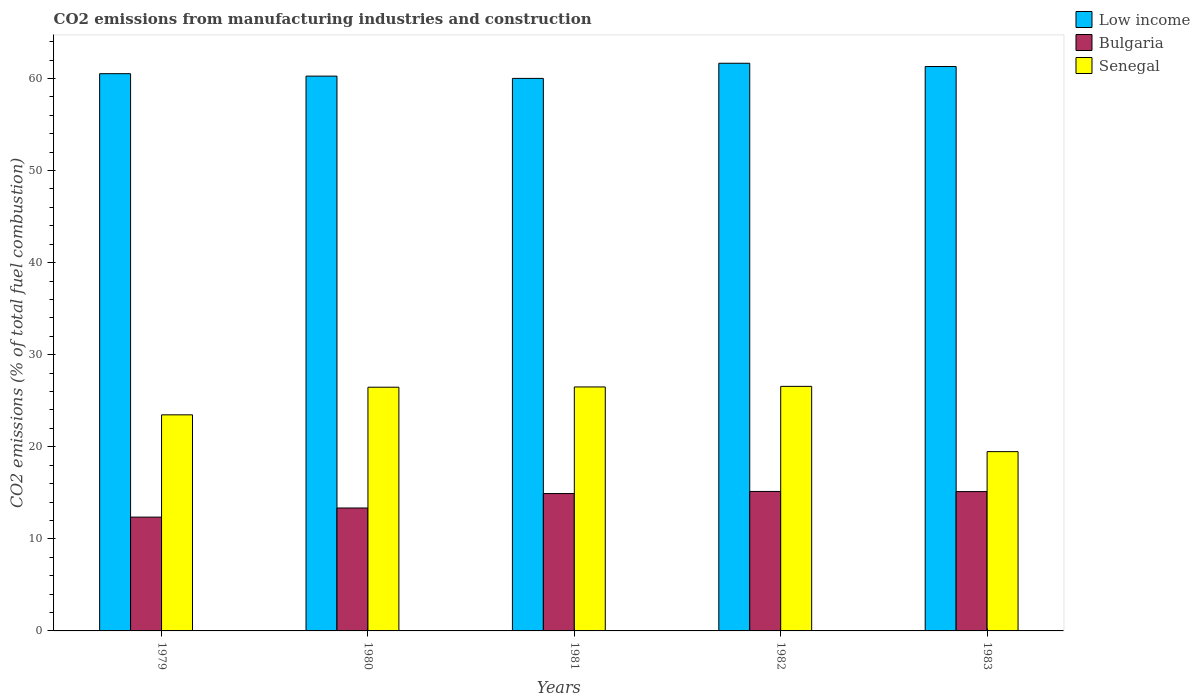How many different coloured bars are there?
Provide a succinct answer. 3. How many groups of bars are there?
Keep it short and to the point. 5. Are the number of bars per tick equal to the number of legend labels?
Provide a succinct answer. Yes. What is the label of the 4th group of bars from the left?
Keep it short and to the point. 1982. What is the amount of CO2 emitted in Senegal in 1983?
Provide a short and direct response. 19.47. Across all years, what is the maximum amount of CO2 emitted in Bulgaria?
Offer a terse response. 15.15. Across all years, what is the minimum amount of CO2 emitted in Bulgaria?
Your answer should be very brief. 12.36. In which year was the amount of CO2 emitted in Senegal maximum?
Provide a short and direct response. 1982. In which year was the amount of CO2 emitted in Bulgaria minimum?
Keep it short and to the point. 1979. What is the total amount of CO2 emitted in Senegal in the graph?
Your answer should be compact. 122.48. What is the difference between the amount of CO2 emitted in Senegal in 1979 and that in 1981?
Provide a succinct answer. -3.03. What is the difference between the amount of CO2 emitted in Bulgaria in 1983 and the amount of CO2 emitted in Low income in 1980?
Your response must be concise. -45.13. What is the average amount of CO2 emitted in Bulgaria per year?
Your response must be concise. 14.18. In the year 1979, what is the difference between the amount of CO2 emitted in Bulgaria and amount of CO2 emitted in Senegal?
Offer a very short reply. -11.11. In how many years, is the amount of CO2 emitted in Senegal greater than 58 %?
Provide a succinct answer. 0. What is the ratio of the amount of CO2 emitted in Senegal in 1980 to that in 1982?
Your answer should be very brief. 1. Is the amount of CO2 emitted in Low income in 1980 less than that in 1981?
Offer a terse response. No. What is the difference between the highest and the second highest amount of CO2 emitted in Senegal?
Provide a short and direct response. 0.06. What is the difference between the highest and the lowest amount of CO2 emitted in Bulgaria?
Make the answer very short. 2.79. Is the sum of the amount of CO2 emitted in Senegal in 1980 and 1981 greater than the maximum amount of CO2 emitted in Bulgaria across all years?
Make the answer very short. Yes. What does the 1st bar from the left in 1983 represents?
Offer a very short reply. Low income. Is it the case that in every year, the sum of the amount of CO2 emitted in Low income and amount of CO2 emitted in Bulgaria is greater than the amount of CO2 emitted in Senegal?
Offer a terse response. Yes. How many years are there in the graph?
Offer a very short reply. 5. What is the difference between two consecutive major ticks on the Y-axis?
Offer a very short reply. 10. Are the values on the major ticks of Y-axis written in scientific E-notation?
Your answer should be very brief. No. Does the graph contain grids?
Provide a succinct answer. No. What is the title of the graph?
Your answer should be very brief. CO2 emissions from manufacturing industries and construction. What is the label or title of the X-axis?
Your response must be concise. Years. What is the label or title of the Y-axis?
Your answer should be compact. CO2 emissions (% of total fuel combustion). What is the CO2 emissions (% of total fuel combustion) of Low income in 1979?
Provide a succinct answer. 60.52. What is the CO2 emissions (% of total fuel combustion) in Bulgaria in 1979?
Make the answer very short. 12.36. What is the CO2 emissions (% of total fuel combustion) of Senegal in 1979?
Your answer should be very brief. 23.47. What is the CO2 emissions (% of total fuel combustion) of Low income in 1980?
Provide a short and direct response. 60.26. What is the CO2 emissions (% of total fuel combustion) in Bulgaria in 1980?
Give a very brief answer. 13.35. What is the CO2 emissions (% of total fuel combustion) of Senegal in 1980?
Offer a terse response. 26.47. What is the CO2 emissions (% of total fuel combustion) in Low income in 1981?
Your answer should be very brief. 60.01. What is the CO2 emissions (% of total fuel combustion) of Bulgaria in 1981?
Keep it short and to the point. 14.92. What is the CO2 emissions (% of total fuel combustion) in Senegal in 1981?
Make the answer very short. 26.5. What is the CO2 emissions (% of total fuel combustion) of Low income in 1982?
Provide a succinct answer. 61.66. What is the CO2 emissions (% of total fuel combustion) of Bulgaria in 1982?
Offer a terse response. 15.15. What is the CO2 emissions (% of total fuel combustion) in Senegal in 1982?
Provide a succinct answer. 26.56. What is the CO2 emissions (% of total fuel combustion) of Low income in 1983?
Provide a succinct answer. 61.3. What is the CO2 emissions (% of total fuel combustion) in Bulgaria in 1983?
Provide a short and direct response. 15.13. What is the CO2 emissions (% of total fuel combustion) in Senegal in 1983?
Ensure brevity in your answer.  19.47. Across all years, what is the maximum CO2 emissions (% of total fuel combustion) of Low income?
Ensure brevity in your answer.  61.66. Across all years, what is the maximum CO2 emissions (% of total fuel combustion) in Bulgaria?
Keep it short and to the point. 15.15. Across all years, what is the maximum CO2 emissions (% of total fuel combustion) of Senegal?
Your response must be concise. 26.56. Across all years, what is the minimum CO2 emissions (% of total fuel combustion) in Low income?
Provide a short and direct response. 60.01. Across all years, what is the minimum CO2 emissions (% of total fuel combustion) of Bulgaria?
Your answer should be very brief. 12.36. Across all years, what is the minimum CO2 emissions (% of total fuel combustion) of Senegal?
Your answer should be very brief. 19.47. What is the total CO2 emissions (% of total fuel combustion) of Low income in the graph?
Your response must be concise. 303.76. What is the total CO2 emissions (% of total fuel combustion) in Bulgaria in the graph?
Your answer should be very brief. 70.92. What is the total CO2 emissions (% of total fuel combustion) in Senegal in the graph?
Your answer should be compact. 122.48. What is the difference between the CO2 emissions (% of total fuel combustion) in Low income in 1979 and that in 1980?
Provide a short and direct response. 0.26. What is the difference between the CO2 emissions (% of total fuel combustion) in Bulgaria in 1979 and that in 1980?
Offer a terse response. -0.99. What is the difference between the CO2 emissions (% of total fuel combustion) of Senegal in 1979 and that in 1980?
Offer a terse response. -3. What is the difference between the CO2 emissions (% of total fuel combustion) of Low income in 1979 and that in 1981?
Offer a terse response. 0.51. What is the difference between the CO2 emissions (% of total fuel combustion) of Bulgaria in 1979 and that in 1981?
Give a very brief answer. -2.56. What is the difference between the CO2 emissions (% of total fuel combustion) in Senegal in 1979 and that in 1981?
Ensure brevity in your answer.  -3.03. What is the difference between the CO2 emissions (% of total fuel combustion) in Low income in 1979 and that in 1982?
Give a very brief answer. -1.13. What is the difference between the CO2 emissions (% of total fuel combustion) in Bulgaria in 1979 and that in 1982?
Ensure brevity in your answer.  -2.79. What is the difference between the CO2 emissions (% of total fuel combustion) in Senegal in 1979 and that in 1982?
Make the answer very short. -3.09. What is the difference between the CO2 emissions (% of total fuel combustion) in Low income in 1979 and that in 1983?
Give a very brief answer. -0.78. What is the difference between the CO2 emissions (% of total fuel combustion) of Bulgaria in 1979 and that in 1983?
Offer a terse response. -2.77. What is the difference between the CO2 emissions (% of total fuel combustion) in Senegal in 1979 and that in 1983?
Ensure brevity in your answer.  4. What is the difference between the CO2 emissions (% of total fuel combustion) in Low income in 1980 and that in 1981?
Give a very brief answer. 0.25. What is the difference between the CO2 emissions (% of total fuel combustion) in Bulgaria in 1980 and that in 1981?
Your response must be concise. -1.57. What is the difference between the CO2 emissions (% of total fuel combustion) of Senegal in 1980 and that in 1981?
Keep it short and to the point. -0.03. What is the difference between the CO2 emissions (% of total fuel combustion) in Low income in 1980 and that in 1982?
Provide a short and direct response. -1.4. What is the difference between the CO2 emissions (% of total fuel combustion) of Bulgaria in 1980 and that in 1982?
Provide a short and direct response. -1.8. What is the difference between the CO2 emissions (% of total fuel combustion) of Senegal in 1980 and that in 1982?
Give a very brief answer. -0.09. What is the difference between the CO2 emissions (% of total fuel combustion) of Low income in 1980 and that in 1983?
Offer a very short reply. -1.04. What is the difference between the CO2 emissions (% of total fuel combustion) of Bulgaria in 1980 and that in 1983?
Offer a very short reply. -1.78. What is the difference between the CO2 emissions (% of total fuel combustion) in Senegal in 1980 and that in 1983?
Keep it short and to the point. 7. What is the difference between the CO2 emissions (% of total fuel combustion) in Low income in 1981 and that in 1982?
Your answer should be compact. -1.64. What is the difference between the CO2 emissions (% of total fuel combustion) in Bulgaria in 1981 and that in 1982?
Offer a very short reply. -0.23. What is the difference between the CO2 emissions (% of total fuel combustion) in Senegal in 1981 and that in 1982?
Provide a short and direct response. -0.06. What is the difference between the CO2 emissions (% of total fuel combustion) in Low income in 1981 and that in 1983?
Provide a short and direct response. -1.29. What is the difference between the CO2 emissions (% of total fuel combustion) of Bulgaria in 1981 and that in 1983?
Offer a terse response. -0.21. What is the difference between the CO2 emissions (% of total fuel combustion) in Senegal in 1981 and that in 1983?
Your answer should be compact. 7.03. What is the difference between the CO2 emissions (% of total fuel combustion) in Low income in 1982 and that in 1983?
Offer a very short reply. 0.35. What is the difference between the CO2 emissions (% of total fuel combustion) in Bulgaria in 1982 and that in 1983?
Offer a very short reply. 0.02. What is the difference between the CO2 emissions (% of total fuel combustion) of Senegal in 1982 and that in 1983?
Offer a terse response. 7.09. What is the difference between the CO2 emissions (% of total fuel combustion) of Low income in 1979 and the CO2 emissions (% of total fuel combustion) of Bulgaria in 1980?
Your response must be concise. 47.17. What is the difference between the CO2 emissions (% of total fuel combustion) of Low income in 1979 and the CO2 emissions (% of total fuel combustion) of Senegal in 1980?
Offer a very short reply. 34.05. What is the difference between the CO2 emissions (% of total fuel combustion) of Bulgaria in 1979 and the CO2 emissions (% of total fuel combustion) of Senegal in 1980?
Your response must be concise. -14.11. What is the difference between the CO2 emissions (% of total fuel combustion) in Low income in 1979 and the CO2 emissions (% of total fuel combustion) in Bulgaria in 1981?
Your answer should be very brief. 45.6. What is the difference between the CO2 emissions (% of total fuel combustion) of Low income in 1979 and the CO2 emissions (% of total fuel combustion) of Senegal in 1981?
Your answer should be compact. 34.02. What is the difference between the CO2 emissions (% of total fuel combustion) of Bulgaria in 1979 and the CO2 emissions (% of total fuel combustion) of Senegal in 1981?
Provide a succinct answer. -14.14. What is the difference between the CO2 emissions (% of total fuel combustion) of Low income in 1979 and the CO2 emissions (% of total fuel combustion) of Bulgaria in 1982?
Keep it short and to the point. 45.37. What is the difference between the CO2 emissions (% of total fuel combustion) in Low income in 1979 and the CO2 emissions (% of total fuel combustion) in Senegal in 1982?
Your answer should be very brief. 33.96. What is the difference between the CO2 emissions (% of total fuel combustion) in Bulgaria in 1979 and the CO2 emissions (% of total fuel combustion) in Senegal in 1982?
Your response must be concise. -14.2. What is the difference between the CO2 emissions (% of total fuel combustion) in Low income in 1979 and the CO2 emissions (% of total fuel combustion) in Bulgaria in 1983?
Offer a very short reply. 45.39. What is the difference between the CO2 emissions (% of total fuel combustion) in Low income in 1979 and the CO2 emissions (% of total fuel combustion) in Senegal in 1983?
Your answer should be compact. 41.05. What is the difference between the CO2 emissions (% of total fuel combustion) of Bulgaria in 1979 and the CO2 emissions (% of total fuel combustion) of Senegal in 1983?
Provide a short and direct response. -7.11. What is the difference between the CO2 emissions (% of total fuel combustion) in Low income in 1980 and the CO2 emissions (% of total fuel combustion) in Bulgaria in 1981?
Provide a succinct answer. 45.34. What is the difference between the CO2 emissions (% of total fuel combustion) in Low income in 1980 and the CO2 emissions (% of total fuel combustion) in Senegal in 1981?
Your answer should be compact. 33.76. What is the difference between the CO2 emissions (% of total fuel combustion) of Bulgaria in 1980 and the CO2 emissions (% of total fuel combustion) of Senegal in 1981?
Ensure brevity in your answer.  -13.15. What is the difference between the CO2 emissions (% of total fuel combustion) of Low income in 1980 and the CO2 emissions (% of total fuel combustion) of Bulgaria in 1982?
Provide a short and direct response. 45.11. What is the difference between the CO2 emissions (% of total fuel combustion) of Low income in 1980 and the CO2 emissions (% of total fuel combustion) of Senegal in 1982?
Make the answer very short. 33.7. What is the difference between the CO2 emissions (% of total fuel combustion) of Bulgaria in 1980 and the CO2 emissions (% of total fuel combustion) of Senegal in 1982?
Give a very brief answer. -13.21. What is the difference between the CO2 emissions (% of total fuel combustion) in Low income in 1980 and the CO2 emissions (% of total fuel combustion) in Bulgaria in 1983?
Your answer should be compact. 45.13. What is the difference between the CO2 emissions (% of total fuel combustion) in Low income in 1980 and the CO2 emissions (% of total fuel combustion) in Senegal in 1983?
Your answer should be compact. 40.79. What is the difference between the CO2 emissions (% of total fuel combustion) in Bulgaria in 1980 and the CO2 emissions (% of total fuel combustion) in Senegal in 1983?
Offer a terse response. -6.12. What is the difference between the CO2 emissions (% of total fuel combustion) in Low income in 1981 and the CO2 emissions (% of total fuel combustion) in Bulgaria in 1982?
Keep it short and to the point. 44.86. What is the difference between the CO2 emissions (% of total fuel combustion) of Low income in 1981 and the CO2 emissions (% of total fuel combustion) of Senegal in 1982?
Make the answer very short. 33.45. What is the difference between the CO2 emissions (% of total fuel combustion) of Bulgaria in 1981 and the CO2 emissions (% of total fuel combustion) of Senegal in 1982?
Ensure brevity in your answer.  -11.64. What is the difference between the CO2 emissions (% of total fuel combustion) of Low income in 1981 and the CO2 emissions (% of total fuel combustion) of Bulgaria in 1983?
Provide a short and direct response. 44.88. What is the difference between the CO2 emissions (% of total fuel combustion) of Low income in 1981 and the CO2 emissions (% of total fuel combustion) of Senegal in 1983?
Give a very brief answer. 40.54. What is the difference between the CO2 emissions (% of total fuel combustion) of Bulgaria in 1981 and the CO2 emissions (% of total fuel combustion) of Senegal in 1983?
Your answer should be compact. -4.55. What is the difference between the CO2 emissions (% of total fuel combustion) of Low income in 1982 and the CO2 emissions (% of total fuel combustion) of Bulgaria in 1983?
Provide a succinct answer. 46.52. What is the difference between the CO2 emissions (% of total fuel combustion) of Low income in 1982 and the CO2 emissions (% of total fuel combustion) of Senegal in 1983?
Provide a short and direct response. 42.18. What is the difference between the CO2 emissions (% of total fuel combustion) of Bulgaria in 1982 and the CO2 emissions (% of total fuel combustion) of Senegal in 1983?
Provide a succinct answer. -4.32. What is the average CO2 emissions (% of total fuel combustion) in Low income per year?
Offer a very short reply. 60.75. What is the average CO2 emissions (% of total fuel combustion) in Bulgaria per year?
Offer a very short reply. 14.18. What is the average CO2 emissions (% of total fuel combustion) in Senegal per year?
Your response must be concise. 24.5. In the year 1979, what is the difference between the CO2 emissions (% of total fuel combustion) of Low income and CO2 emissions (% of total fuel combustion) of Bulgaria?
Ensure brevity in your answer.  48.16. In the year 1979, what is the difference between the CO2 emissions (% of total fuel combustion) in Low income and CO2 emissions (% of total fuel combustion) in Senegal?
Your answer should be compact. 37.05. In the year 1979, what is the difference between the CO2 emissions (% of total fuel combustion) in Bulgaria and CO2 emissions (% of total fuel combustion) in Senegal?
Offer a terse response. -11.11. In the year 1980, what is the difference between the CO2 emissions (% of total fuel combustion) of Low income and CO2 emissions (% of total fuel combustion) of Bulgaria?
Provide a succinct answer. 46.91. In the year 1980, what is the difference between the CO2 emissions (% of total fuel combustion) in Low income and CO2 emissions (% of total fuel combustion) in Senegal?
Provide a short and direct response. 33.79. In the year 1980, what is the difference between the CO2 emissions (% of total fuel combustion) of Bulgaria and CO2 emissions (% of total fuel combustion) of Senegal?
Your response must be concise. -13.12. In the year 1981, what is the difference between the CO2 emissions (% of total fuel combustion) in Low income and CO2 emissions (% of total fuel combustion) in Bulgaria?
Keep it short and to the point. 45.09. In the year 1981, what is the difference between the CO2 emissions (% of total fuel combustion) of Low income and CO2 emissions (% of total fuel combustion) of Senegal?
Your answer should be compact. 33.51. In the year 1981, what is the difference between the CO2 emissions (% of total fuel combustion) in Bulgaria and CO2 emissions (% of total fuel combustion) in Senegal?
Ensure brevity in your answer.  -11.58. In the year 1982, what is the difference between the CO2 emissions (% of total fuel combustion) in Low income and CO2 emissions (% of total fuel combustion) in Bulgaria?
Make the answer very short. 46.51. In the year 1982, what is the difference between the CO2 emissions (% of total fuel combustion) of Low income and CO2 emissions (% of total fuel combustion) of Senegal?
Provide a succinct answer. 35.09. In the year 1982, what is the difference between the CO2 emissions (% of total fuel combustion) of Bulgaria and CO2 emissions (% of total fuel combustion) of Senegal?
Offer a terse response. -11.41. In the year 1983, what is the difference between the CO2 emissions (% of total fuel combustion) of Low income and CO2 emissions (% of total fuel combustion) of Bulgaria?
Make the answer very short. 46.17. In the year 1983, what is the difference between the CO2 emissions (% of total fuel combustion) in Low income and CO2 emissions (% of total fuel combustion) in Senegal?
Ensure brevity in your answer.  41.83. In the year 1983, what is the difference between the CO2 emissions (% of total fuel combustion) in Bulgaria and CO2 emissions (% of total fuel combustion) in Senegal?
Make the answer very short. -4.34. What is the ratio of the CO2 emissions (% of total fuel combustion) in Bulgaria in 1979 to that in 1980?
Keep it short and to the point. 0.93. What is the ratio of the CO2 emissions (% of total fuel combustion) in Senegal in 1979 to that in 1980?
Your response must be concise. 0.89. What is the ratio of the CO2 emissions (% of total fuel combustion) of Low income in 1979 to that in 1981?
Make the answer very short. 1.01. What is the ratio of the CO2 emissions (% of total fuel combustion) of Bulgaria in 1979 to that in 1981?
Your answer should be very brief. 0.83. What is the ratio of the CO2 emissions (% of total fuel combustion) of Senegal in 1979 to that in 1981?
Ensure brevity in your answer.  0.89. What is the ratio of the CO2 emissions (% of total fuel combustion) of Low income in 1979 to that in 1982?
Keep it short and to the point. 0.98. What is the ratio of the CO2 emissions (% of total fuel combustion) in Bulgaria in 1979 to that in 1982?
Ensure brevity in your answer.  0.82. What is the ratio of the CO2 emissions (% of total fuel combustion) of Senegal in 1979 to that in 1982?
Offer a terse response. 0.88. What is the ratio of the CO2 emissions (% of total fuel combustion) of Low income in 1979 to that in 1983?
Your answer should be compact. 0.99. What is the ratio of the CO2 emissions (% of total fuel combustion) in Bulgaria in 1979 to that in 1983?
Ensure brevity in your answer.  0.82. What is the ratio of the CO2 emissions (% of total fuel combustion) in Senegal in 1979 to that in 1983?
Your answer should be very brief. 1.21. What is the ratio of the CO2 emissions (% of total fuel combustion) in Bulgaria in 1980 to that in 1981?
Your answer should be compact. 0.89. What is the ratio of the CO2 emissions (% of total fuel combustion) in Low income in 1980 to that in 1982?
Give a very brief answer. 0.98. What is the ratio of the CO2 emissions (% of total fuel combustion) in Bulgaria in 1980 to that in 1982?
Ensure brevity in your answer.  0.88. What is the ratio of the CO2 emissions (% of total fuel combustion) of Low income in 1980 to that in 1983?
Give a very brief answer. 0.98. What is the ratio of the CO2 emissions (% of total fuel combustion) of Bulgaria in 1980 to that in 1983?
Keep it short and to the point. 0.88. What is the ratio of the CO2 emissions (% of total fuel combustion) in Senegal in 1980 to that in 1983?
Your response must be concise. 1.36. What is the ratio of the CO2 emissions (% of total fuel combustion) in Low income in 1981 to that in 1982?
Your response must be concise. 0.97. What is the ratio of the CO2 emissions (% of total fuel combustion) in Senegal in 1981 to that in 1982?
Your response must be concise. 1. What is the ratio of the CO2 emissions (% of total fuel combustion) in Low income in 1981 to that in 1983?
Keep it short and to the point. 0.98. What is the ratio of the CO2 emissions (% of total fuel combustion) of Senegal in 1981 to that in 1983?
Make the answer very short. 1.36. What is the ratio of the CO2 emissions (% of total fuel combustion) of Low income in 1982 to that in 1983?
Provide a short and direct response. 1.01. What is the ratio of the CO2 emissions (% of total fuel combustion) in Bulgaria in 1982 to that in 1983?
Provide a short and direct response. 1. What is the ratio of the CO2 emissions (% of total fuel combustion) of Senegal in 1982 to that in 1983?
Your response must be concise. 1.36. What is the difference between the highest and the second highest CO2 emissions (% of total fuel combustion) of Low income?
Offer a very short reply. 0.35. What is the difference between the highest and the second highest CO2 emissions (% of total fuel combustion) of Bulgaria?
Offer a terse response. 0.02. What is the difference between the highest and the second highest CO2 emissions (% of total fuel combustion) in Senegal?
Your response must be concise. 0.06. What is the difference between the highest and the lowest CO2 emissions (% of total fuel combustion) in Low income?
Offer a very short reply. 1.64. What is the difference between the highest and the lowest CO2 emissions (% of total fuel combustion) in Bulgaria?
Give a very brief answer. 2.79. What is the difference between the highest and the lowest CO2 emissions (% of total fuel combustion) in Senegal?
Offer a terse response. 7.09. 